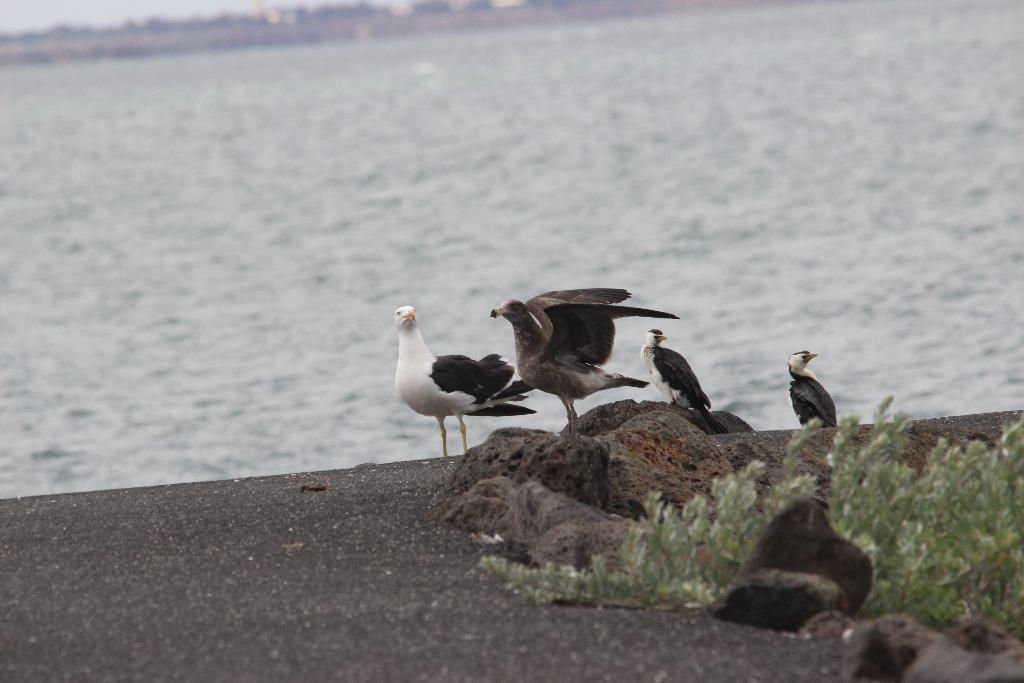What type of animals can be seen on the ground in the image? There is a group of birds on the ground in the image. What objects are present in the foreground of the image? Rocks and plants are visible in the foreground of the image. What can be seen in the background of the image? There is water visible in the background of the image. What type of religious symbol can be seen hanging from the hook in the image? There is no hook or religious symbol present in the image. 